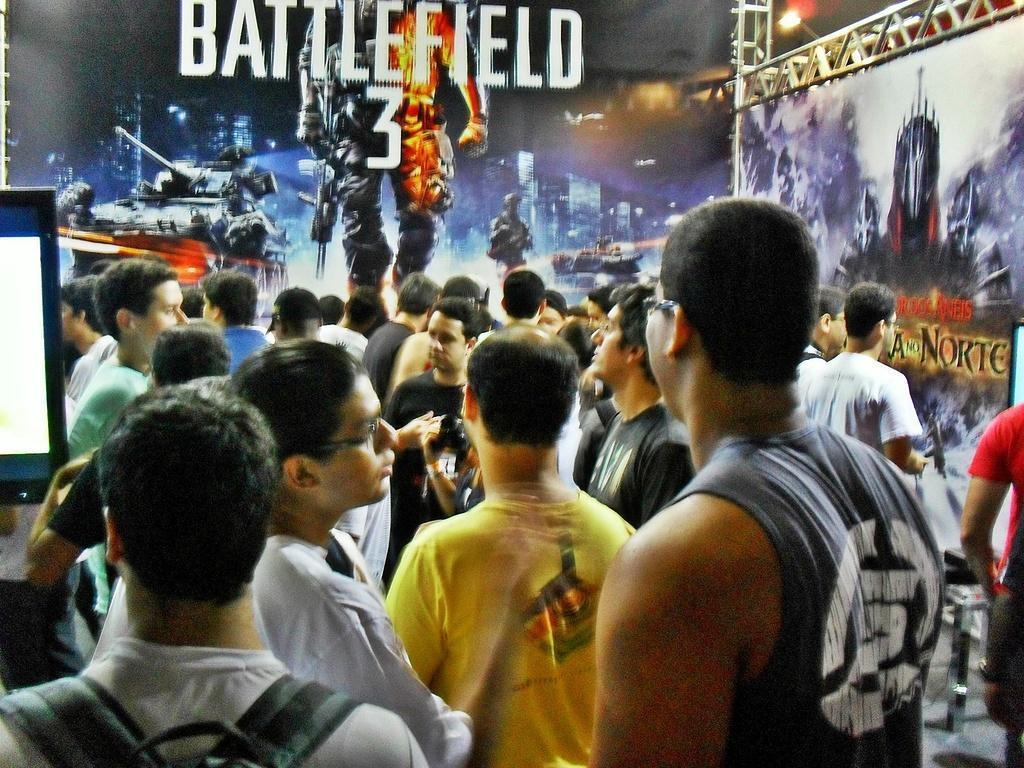How many people are in the image? There is a group of people in the image, but the exact number cannot be determined from the provided facts. What is located on the left side of the image? There is a monitor screen on the left side of the image. What can be seen in the background of the image? There are posters and rods in the background of the image. What type of hose is being used for the competition in the image? There is no hose or competition present in the image. What religious symbols can be seen in the image? There is no mention of religious symbols in the provided facts, so we cannot determine if any are present in the image. 